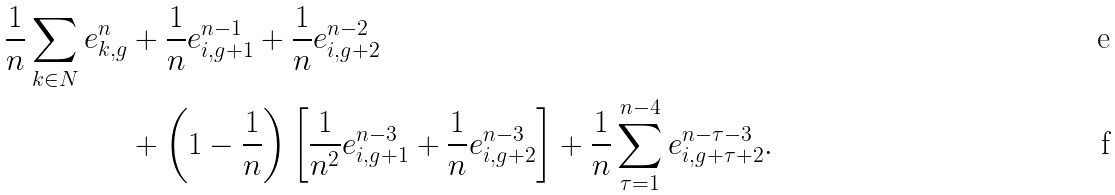Convert formula to latex. <formula><loc_0><loc_0><loc_500><loc_500>\frac { 1 } { n } \sum _ { k \in N } e _ { k , g } ^ { n } & + \frac { 1 } { n } e ^ { n - 1 } _ { i , g + 1 } + \frac { 1 } { n } e _ { i , g + 2 } ^ { n - 2 } \\ & + \left ( 1 - \frac { 1 } { n } \right ) \left [ \frac { 1 } { n ^ { 2 } } e _ { i , g + 1 } ^ { n - 3 } + \frac { 1 } { n } e _ { i , g + 2 } ^ { n - 3 } \right ] + \frac { 1 } { n } \sum _ { \tau = 1 } ^ { n - 4 } e _ { i , g + \tau + 2 } ^ { n - \tau - 3 } .</formula> 